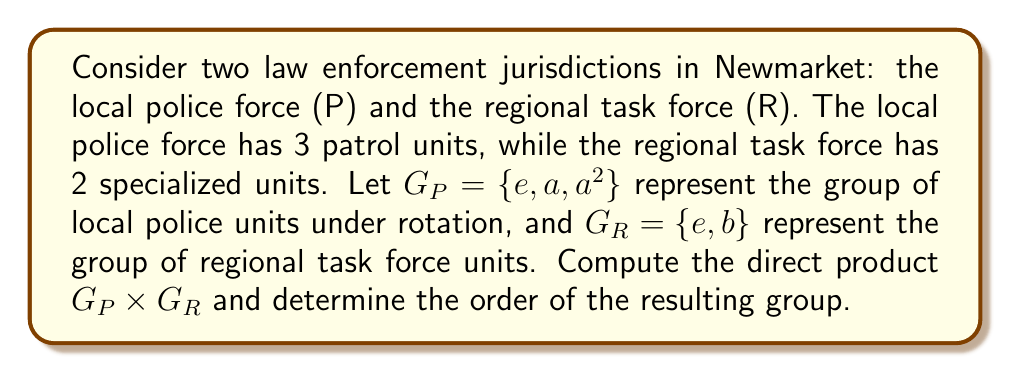What is the answer to this math problem? To solve this problem, we need to follow these steps:

1) First, recall that the direct product of two groups $G_1$ and $G_2$ is defined as:

   $G_1 \times G_2 = \{(g_1, g_2) | g_1 \in G_1, g_2 \in G_2\}$

   with the operation $(g_1, g_2) * (h_1, h_2) = (g_1 * h_1, g_2 * h_2)$

2) In our case, $G_P = \{e, a, a^2\}$ and $G_R = \{e, b\}$

3) To compute $G_P \times G_R$, we need to pair each element of $G_P$ with each element of $G_R$:

   $G_P \times G_R = \{(e,e), (e,b), (a,e), (a,b), (a^2,e), (a^2,b)\}$

4) To determine the order of the resulting group, we simply count the number of elements in the direct product. 

   $|G_P \times G_R| = |G_P| \cdot |G_R| = 3 \cdot 2 = 6$

Therefore, the direct product $G_P \times G_R$ has 6 elements, representing all possible combinations of local police units and regional task force units working together in Newmarket.
Answer: The direct product $G_P \times G_R = \{(e,e), (e,b), (a,e), (a,b), (a^2,e), (a^2,b)\}$, and its order is 6. 